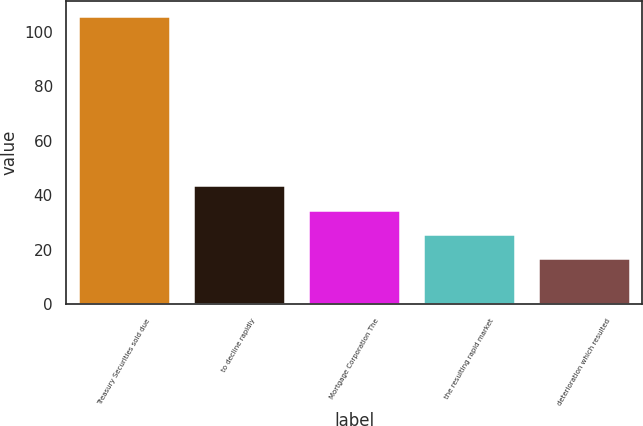<chart> <loc_0><loc_0><loc_500><loc_500><bar_chart><fcel>Treasury Securities sold due<fcel>to decline rapidly<fcel>Mortgage Corporation The<fcel>the resulting rapid market<fcel>deterioration which resulted<nl><fcel>106<fcel>43.7<fcel>34.8<fcel>25.9<fcel>17<nl></chart> 